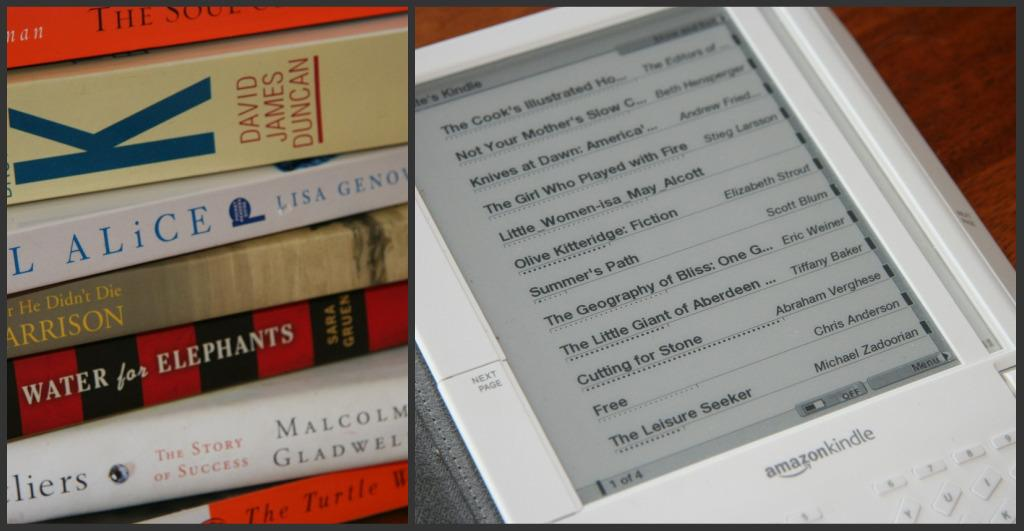<image>
Offer a succinct explanation of the picture presented. A stack of books next to an Amazon Kindle 